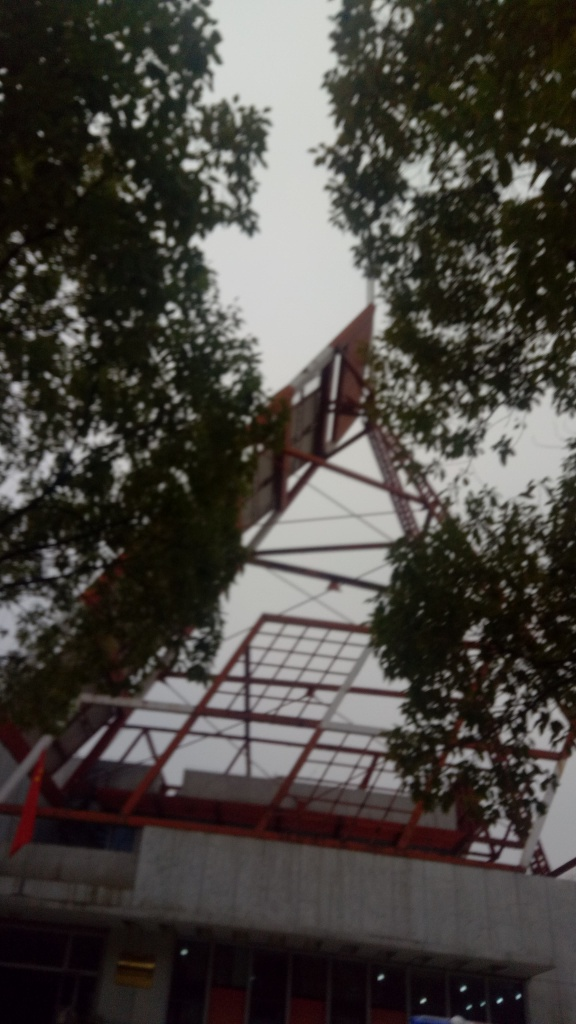Is the saturation low? The image appears to have low saturation, with the colors looking quite muted and lacking in intensity, which is often indicative of either an overcast sky or a photographic effect. 